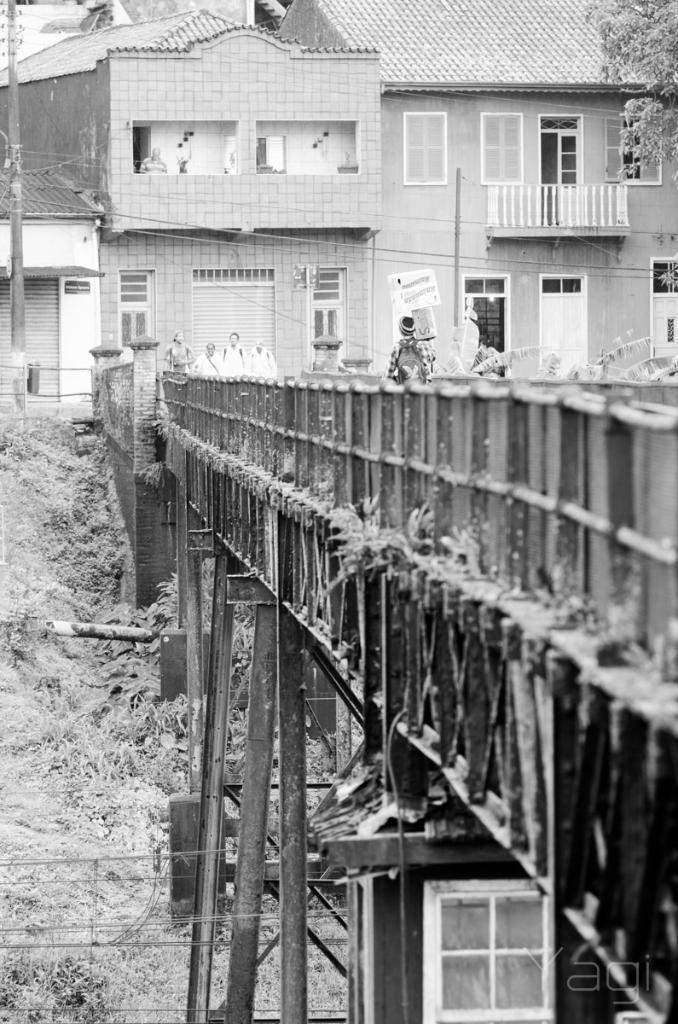Describe this image in one or two sentences. This image consists of a building along with windows and door. In the front, there is a bridge made up of metal. At the bottom, there is a ground. To the top right, there is a tree. 